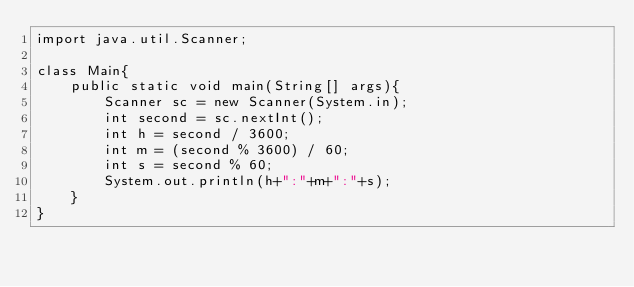Convert code to text. <code><loc_0><loc_0><loc_500><loc_500><_Java_>import java.util.Scanner;

class Main{
    public static void main(String[] args){
        Scanner sc = new Scanner(System.in);
        int second = sc.nextInt();
        int h = second / 3600;
        int m = (second % 3600) / 60;
        int s = second % 60;
        System.out.println(h+":"+m+":"+s);
    }
}
</code> 